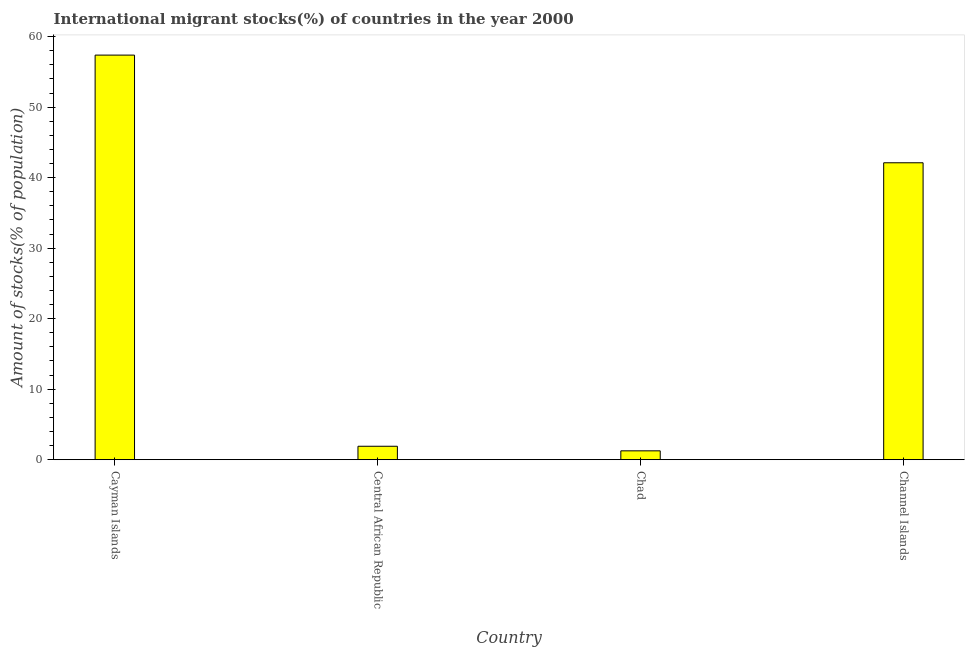Does the graph contain grids?
Give a very brief answer. No. What is the title of the graph?
Offer a terse response. International migrant stocks(%) of countries in the year 2000. What is the label or title of the Y-axis?
Ensure brevity in your answer.  Amount of stocks(% of population). What is the number of international migrant stocks in Central African Republic?
Ensure brevity in your answer.  1.91. Across all countries, what is the maximum number of international migrant stocks?
Make the answer very short. 57.38. Across all countries, what is the minimum number of international migrant stocks?
Provide a short and direct response. 1.26. In which country was the number of international migrant stocks maximum?
Provide a succinct answer. Cayman Islands. In which country was the number of international migrant stocks minimum?
Provide a succinct answer. Chad. What is the sum of the number of international migrant stocks?
Offer a terse response. 102.66. What is the difference between the number of international migrant stocks in Central African Republic and Channel Islands?
Keep it short and to the point. -40.2. What is the average number of international migrant stocks per country?
Provide a succinct answer. 25.66. What is the median number of international migrant stocks?
Provide a short and direct response. 22.01. In how many countries, is the number of international migrant stocks greater than 26 %?
Your response must be concise. 2. What is the ratio of the number of international migrant stocks in Cayman Islands to that in Central African Republic?
Your response must be concise. 30.09. Is the difference between the number of international migrant stocks in Cayman Islands and Channel Islands greater than the difference between any two countries?
Your answer should be compact. No. What is the difference between the highest and the second highest number of international migrant stocks?
Offer a very short reply. 15.27. Is the sum of the number of international migrant stocks in Cayman Islands and Chad greater than the maximum number of international migrant stocks across all countries?
Provide a succinct answer. Yes. What is the difference between the highest and the lowest number of international migrant stocks?
Ensure brevity in your answer.  56.13. In how many countries, is the number of international migrant stocks greater than the average number of international migrant stocks taken over all countries?
Your answer should be compact. 2. What is the difference between two consecutive major ticks on the Y-axis?
Keep it short and to the point. 10. What is the Amount of stocks(% of population) in Cayman Islands?
Keep it short and to the point. 57.38. What is the Amount of stocks(% of population) in Central African Republic?
Provide a short and direct response. 1.91. What is the Amount of stocks(% of population) of Chad?
Keep it short and to the point. 1.26. What is the Amount of stocks(% of population) in Channel Islands?
Your response must be concise. 42.11. What is the difference between the Amount of stocks(% of population) in Cayman Islands and Central African Republic?
Your response must be concise. 55.48. What is the difference between the Amount of stocks(% of population) in Cayman Islands and Chad?
Give a very brief answer. 56.13. What is the difference between the Amount of stocks(% of population) in Cayman Islands and Channel Islands?
Make the answer very short. 15.27. What is the difference between the Amount of stocks(% of population) in Central African Republic and Chad?
Provide a short and direct response. 0.65. What is the difference between the Amount of stocks(% of population) in Central African Republic and Channel Islands?
Your answer should be very brief. -40.2. What is the difference between the Amount of stocks(% of population) in Chad and Channel Islands?
Provide a short and direct response. -40.85. What is the ratio of the Amount of stocks(% of population) in Cayman Islands to that in Central African Republic?
Offer a terse response. 30.09. What is the ratio of the Amount of stocks(% of population) in Cayman Islands to that in Chad?
Your response must be concise. 45.67. What is the ratio of the Amount of stocks(% of population) in Cayman Islands to that in Channel Islands?
Provide a short and direct response. 1.36. What is the ratio of the Amount of stocks(% of population) in Central African Republic to that in Chad?
Provide a succinct answer. 1.52. What is the ratio of the Amount of stocks(% of population) in Central African Republic to that in Channel Islands?
Offer a very short reply. 0.04. 